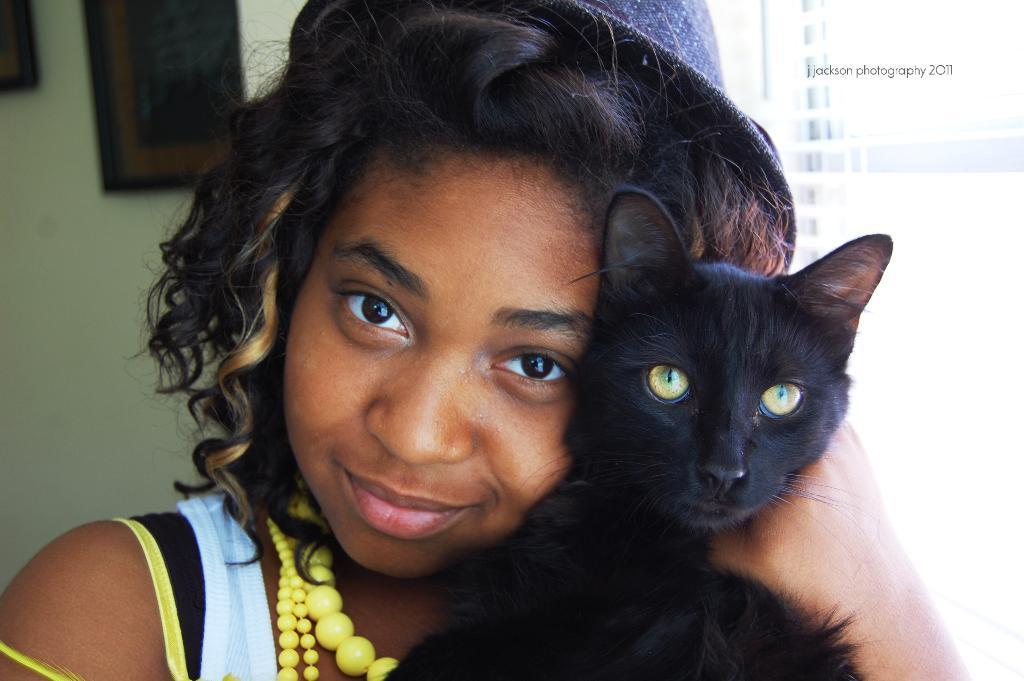Can you describe this image briefly? As we can see in the image there is a wall and a woman holding black color cat. 